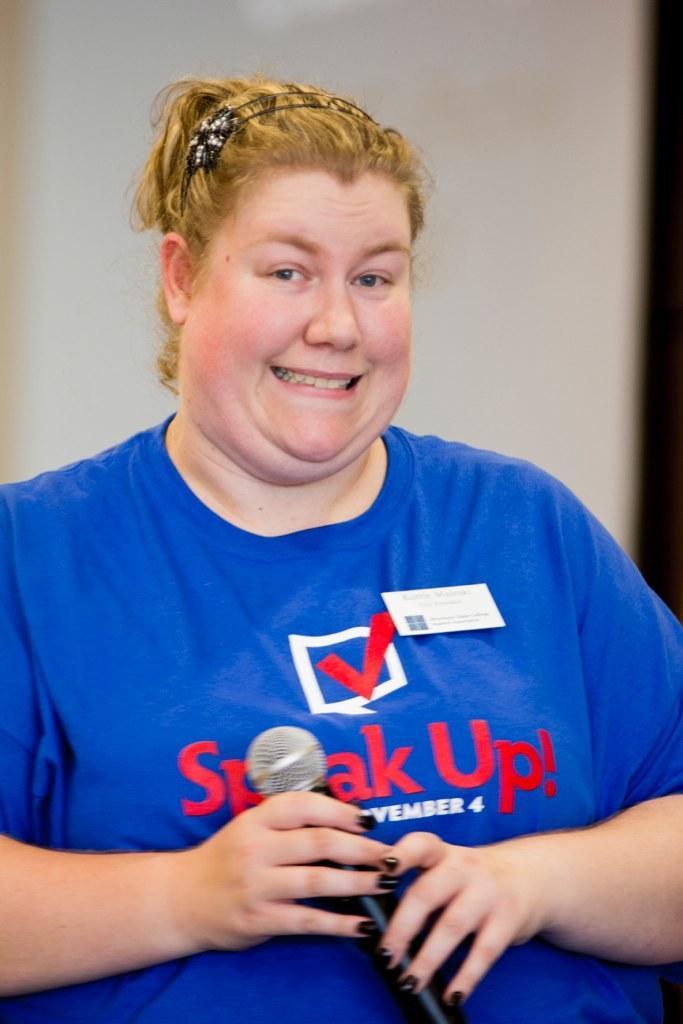Could you give a brief overview of what you see in this image? A lady with blue t-shirt is standing and holding a mic in her hands. She is smiling. 